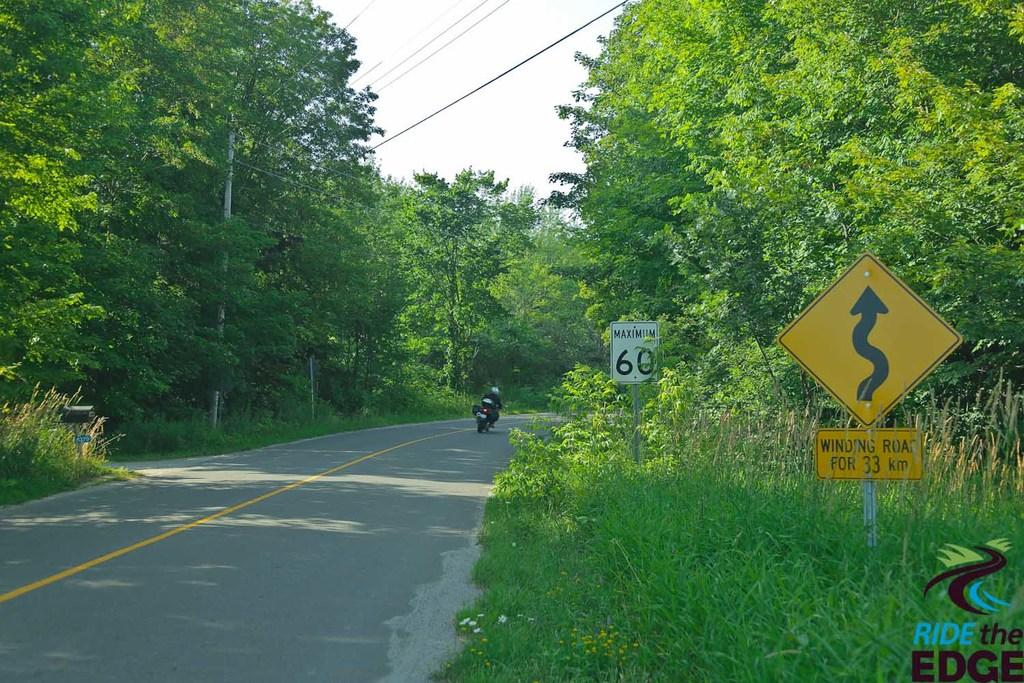Provide a one-sentence caption for the provided image. A motorbike flies along a country road passing warning signs and a 60 speed limit sign. 